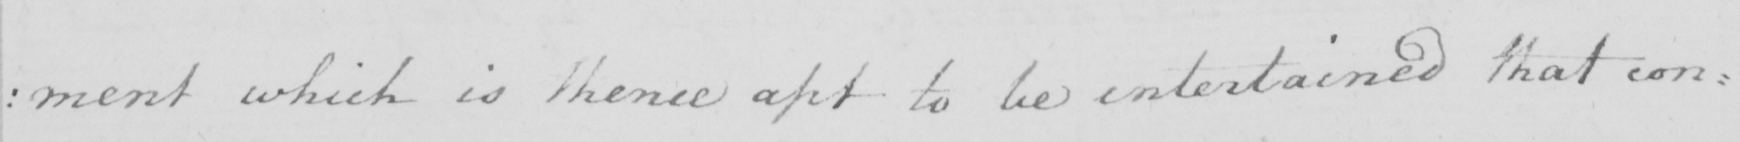Please transcribe the handwritten text in this image. : ment which is thence apt to be entertained that con= 